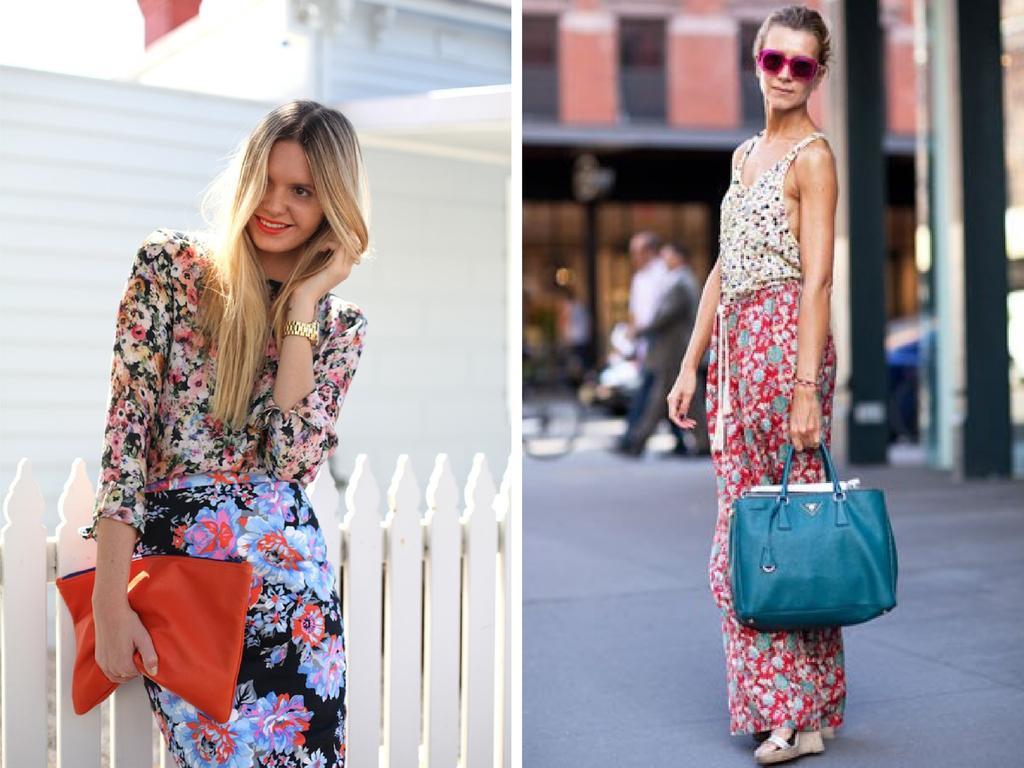Describe this image in one or two sentences. On the right side of the image there is a woman holding a blue color bag in her left hand. The woman who is on the left side is holding a red color bag and wearing a watch to her left hand. In the background I can see a building and few people are walking on the road. 